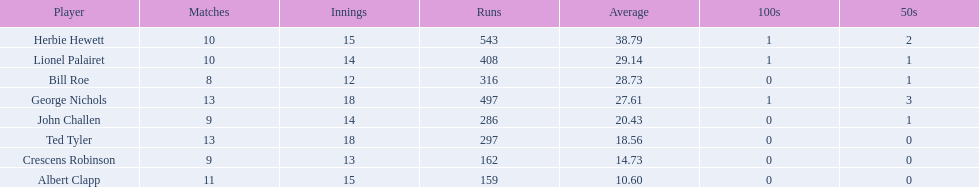What was the total count of innings for albert clapp? 15. 